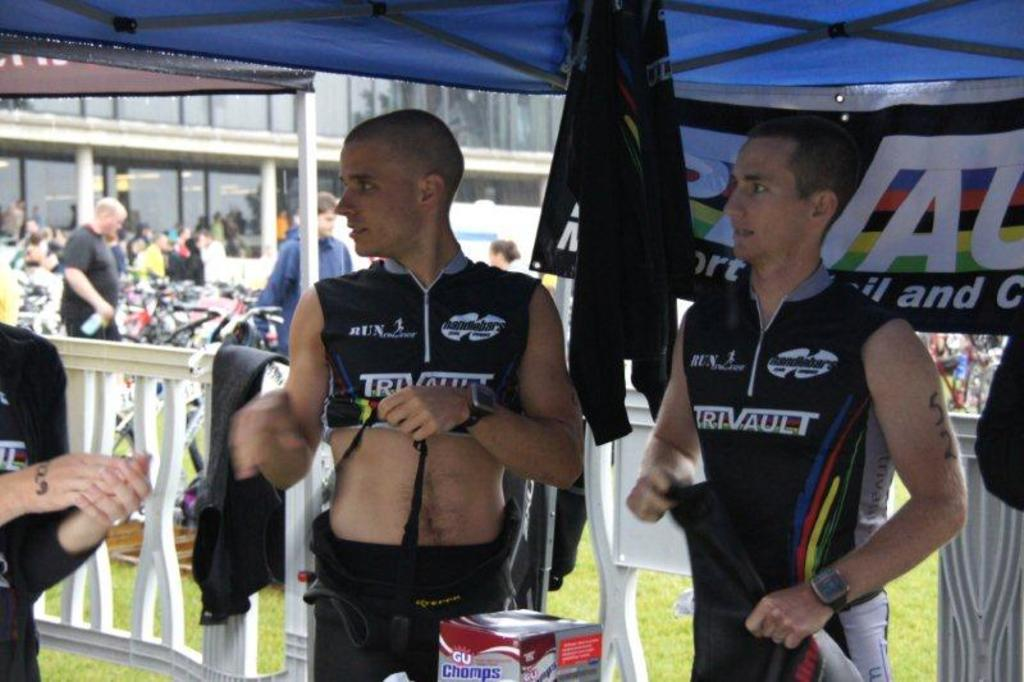<image>
Write a terse but informative summary of the picture. Two men wearing TRIVAULT jerseys stand next to each other 